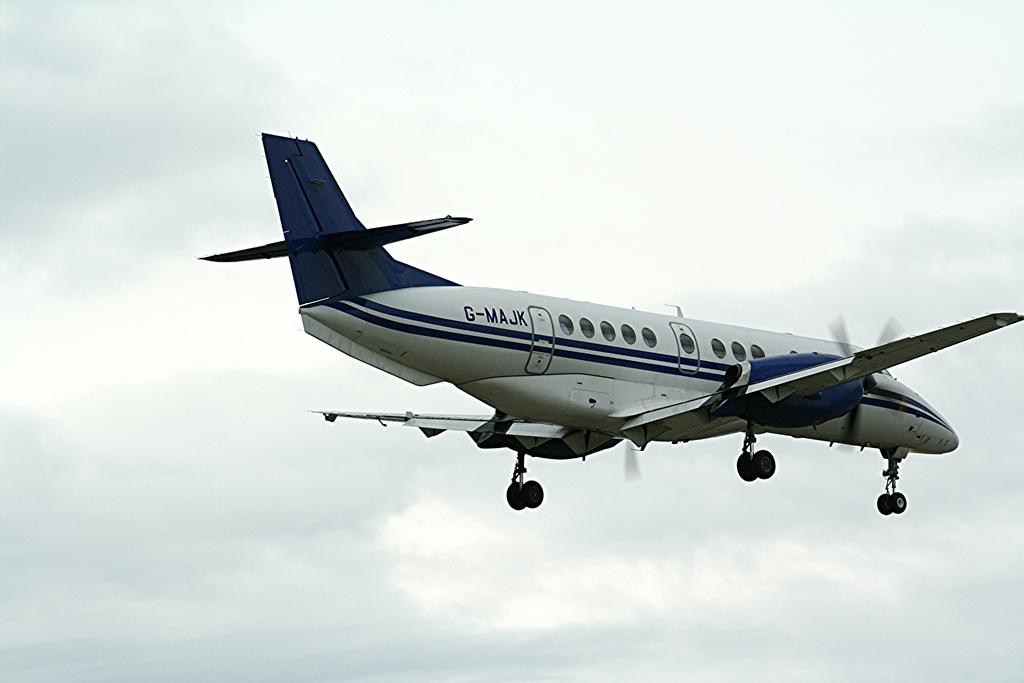What is the tail number of this plane?
Keep it short and to the point. G-majk. 